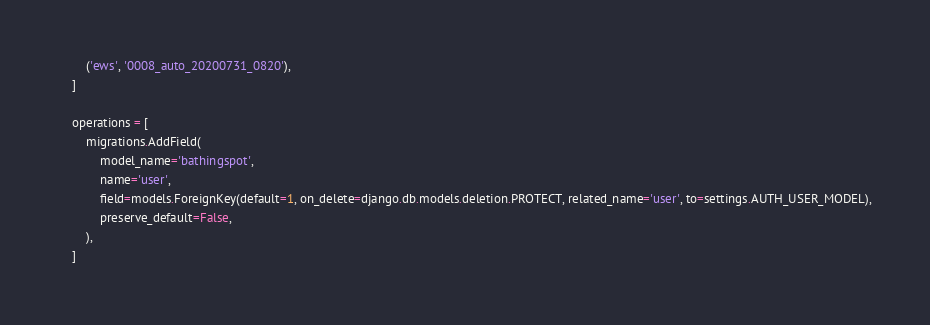<code> <loc_0><loc_0><loc_500><loc_500><_Python_>        ('ews', '0008_auto_20200731_0820'),
    ]

    operations = [
        migrations.AddField(
            model_name='bathingspot',
            name='user',
            field=models.ForeignKey(default=1, on_delete=django.db.models.deletion.PROTECT, related_name='user', to=settings.AUTH_USER_MODEL),
            preserve_default=False,
        ),
    ]
</code> 